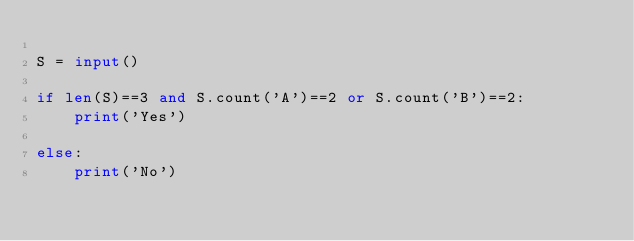<code> <loc_0><loc_0><loc_500><loc_500><_Python_>
S = input()

if len(S)==3 and S.count('A')==2 or S.count('B')==2:
    print('Yes')

else:
    print('No')</code> 